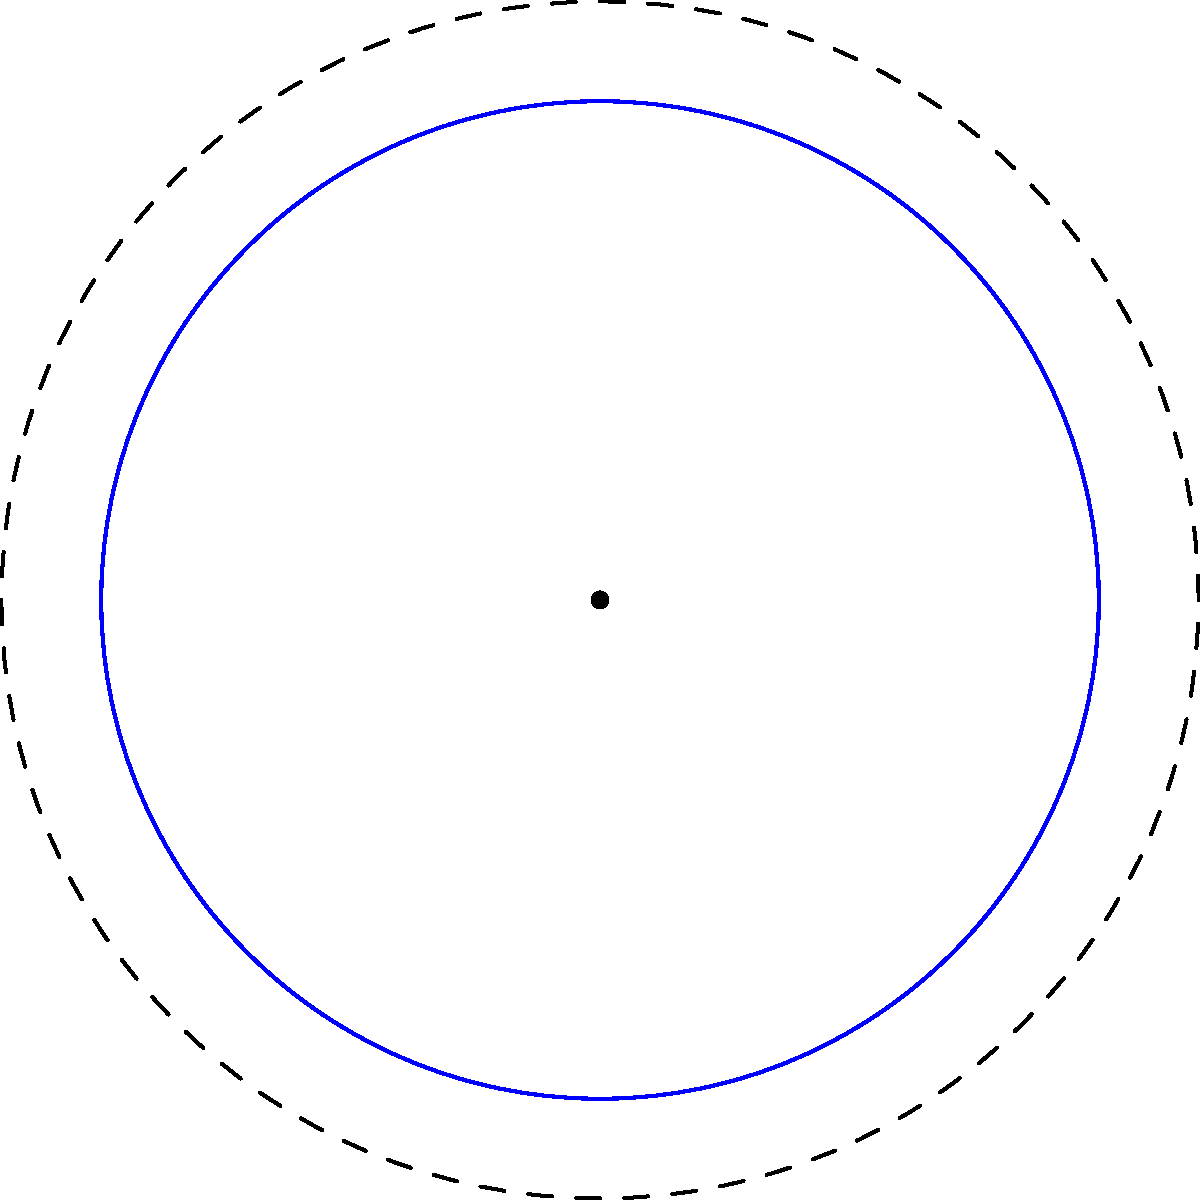In your role as a museum professional, you're analyzing an ancient pottery pattern that exhibits a five-fold rotational symmetry, as shown in the diagram. What is the order of the cyclic group that describes this symmetry, and how might this information enhance the holistic presentation of this artifact to museum visitors? To answer this question, let's approach it step-by-step:

1. Observe the pattern: The diagram shows a design with 5 identical elements arranged in a circular pattern.

2. Identify the symmetry: This pattern exhibits rotational symmetry, where the design looks the same after being rotated by a certain angle.

3. Determine the symmetry operations:
   - The pattern remains unchanged when rotated by 72° (360° / 5)
   - It also remains unchanged when rotated by 144° (2 * 72°), 216° (3 * 72°), 288° (4 * 72°), and 360° (5 * 72°)

4. Identify the group: These rotations form a cyclic group, denoted as $C_5$ or $\mathbb{Z}_5$.

5. Determine the order of the group: The order is the number of elements in the group, which is 5 in this case.

6. Holistic presentation:
   - This symmetry reflects the mathematical knowledge and aesthetic preferences of the ancient civilization.
   - It could indicate cultural or religious significance of the number 5.
   - Comparing with other artifacts might reveal patterns in mathematical understanding across different ancient cultures.
   - This could be used to discuss the universality of mathematical concepts and their expression in art.
Answer: Order 5; enhances understanding of ancient mathematical knowledge and cultural significance. 